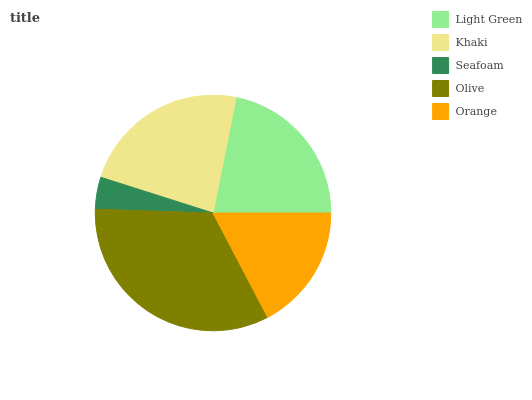Is Seafoam the minimum?
Answer yes or no. Yes. Is Olive the maximum?
Answer yes or no. Yes. Is Khaki the minimum?
Answer yes or no. No. Is Khaki the maximum?
Answer yes or no. No. Is Khaki greater than Light Green?
Answer yes or no. Yes. Is Light Green less than Khaki?
Answer yes or no. Yes. Is Light Green greater than Khaki?
Answer yes or no. No. Is Khaki less than Light Green?
Answer yes or no. No. Is Light Green the high median?
Answer yes or no. Yes. Is Light Green the low median?
Answer yes or no. Yes. Is Olive the high median?
Answer yes or no. No. Is Seafoam the low median?
Answer yes or no. No. 